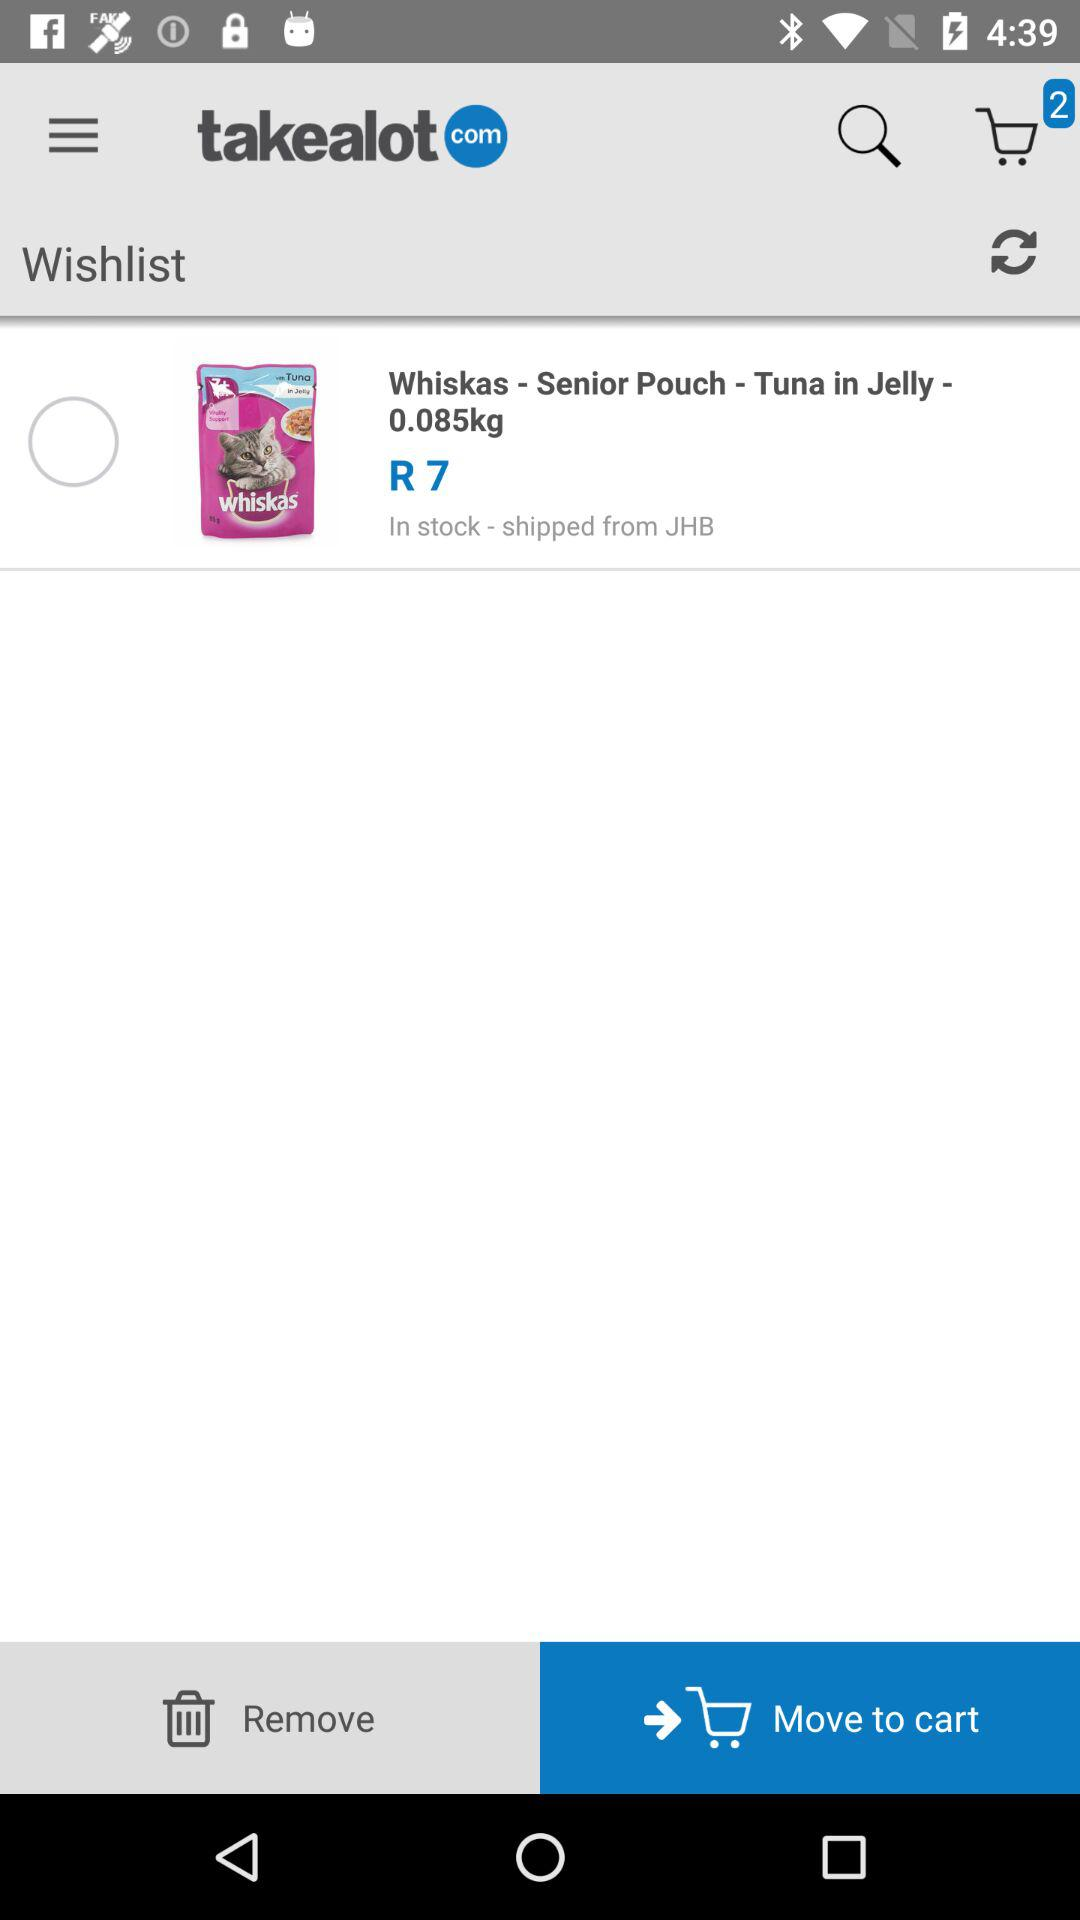What is the name of the application? The name of the application is "takealot". 